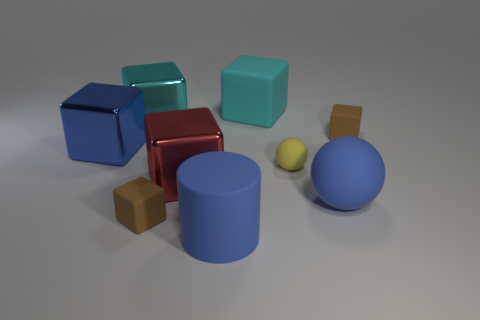There is a metallic cube that is right of the big cyan metallic thing; does it have the same color as the tiny thing to the left of the matte cylinder?
Your answer should be compact. No. The cyan thing that is on the left side of the rubber cube in front of the blue block is made of what material?
Offer a terse response. Metal. What is the color of the matte cube that is the same size as the cyan shiny cube?
Give a very brief answer. Cyan. Does the yellow object have the same shape as the brown thing that is on the left side of the big red shiny object?
Keep it short and to the point. No. The big matte object that is the same color as the big cylinder is what shape?
Make the answer very short. Sphere. There is a small cube on the left side of the brown rubber cube that is behind the big rubber sphere; what number of small yellow rubber balls are behind it?
Make the answer very short. 1. There is a blue object in front of the big sphere right of the yellow rubber sphere; how big is it?
Your answer should be compact. Large. There is a yellow object that is made of the same material as the blue ball; what is its size?
Offer a terse response. Small. There is a big object that is behind the tiny yellow rubber thing and to the right of the large red metal thing; what is its shape?
Offer a very short reply. Cube. Are there an equal number of cyan shiny cubes to the right of the tiny yellow ball and green metallic cylinders?
Offer a terse response. Yes. 